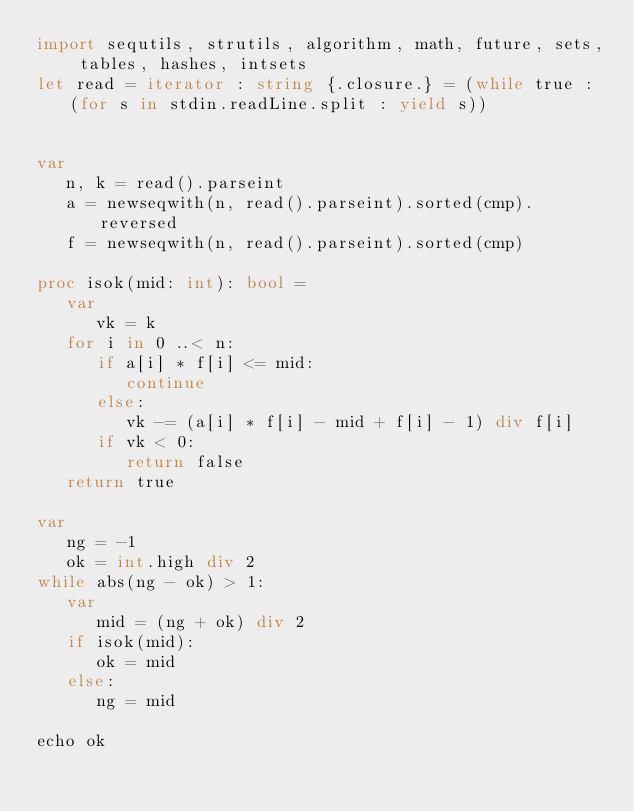Convert code to text. <code><loc_0><loc_0><loc_500><loc_500><_Nim_>import sequtils, strutils, algorithm, math, future, sets, tables, hashes, intsets
let read = iterator : string {.closure.} = (while true : (for s in stdin.readLine.split : yield s))


var
   n, k = read().parseint
   a = newseqwith(n, read().parseint).sorted(cmp).reversed
   f = newseqwith(n, read().parseint).sorted(cmp)

proc isok(mid: int): bool = 
   var
      vk = k
   for i in 0 ..< n:
      if a[i] * f[i] <= mid:
         continue
      else:
         vk -= (a[i] * f[i] - mid + f[i] - 1) div f[i]
      if vk < 0:
         return false
   return true

var
   ng = -1
   ok = int.high div 2
while abs(ng - ok) > 1:
   var
      mid = (ng + ok) div 2
   if isok(mid):
      ok = mid
   else:
      ng = mid

echo ok



</code> 